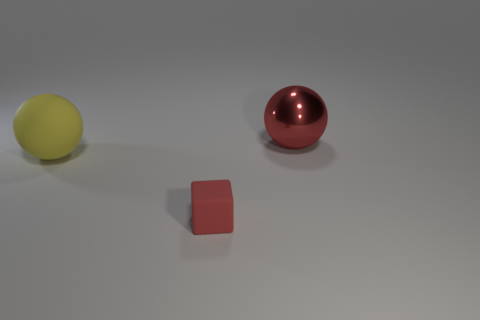Add 3 red rubber blocks. How many objects exist? 6 Subtract all blocks. How many objects are left? 2 Subtract 0 green cylinders. How many objects are left? 3 Subtract all big red metallic balls. Subtract all small red things. How many objects are left? 1 Add 2 small things. How many small things are left? 3 Add 1 big rubber objects. How many big rubber objects exist? 2 